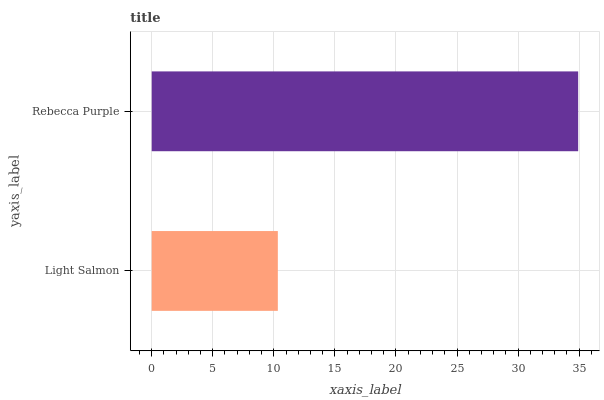Is Light Salmon the minimum?
Answer yes or no. Yes. Is Rebecca Purple the maximum?
Answer yes or no. Yes. Is Rebecca Purple the minimum?
Answer yes or no. No. Is Rebecca Purple greater than Light Salmon?
Answer yes or no. Yes. Is Light Salmon less than Rebecca Purple?
Answer yes or no. Yes. Is Light Salmon greater than Rebecca Purple?
Answer yes or no. No. Is Rebecca Purple less than Light Salmon?
Answer yes or no. No. Is Rebecca Purple the high median?
Answer yes or no. Yes. Is Light Salmon the low median?
Answer yes or no. Yes. Is Light Salmon the high median?
Answer yes or no. No. Is Rebecca Purple the low median?
Answer yes or no. No. 